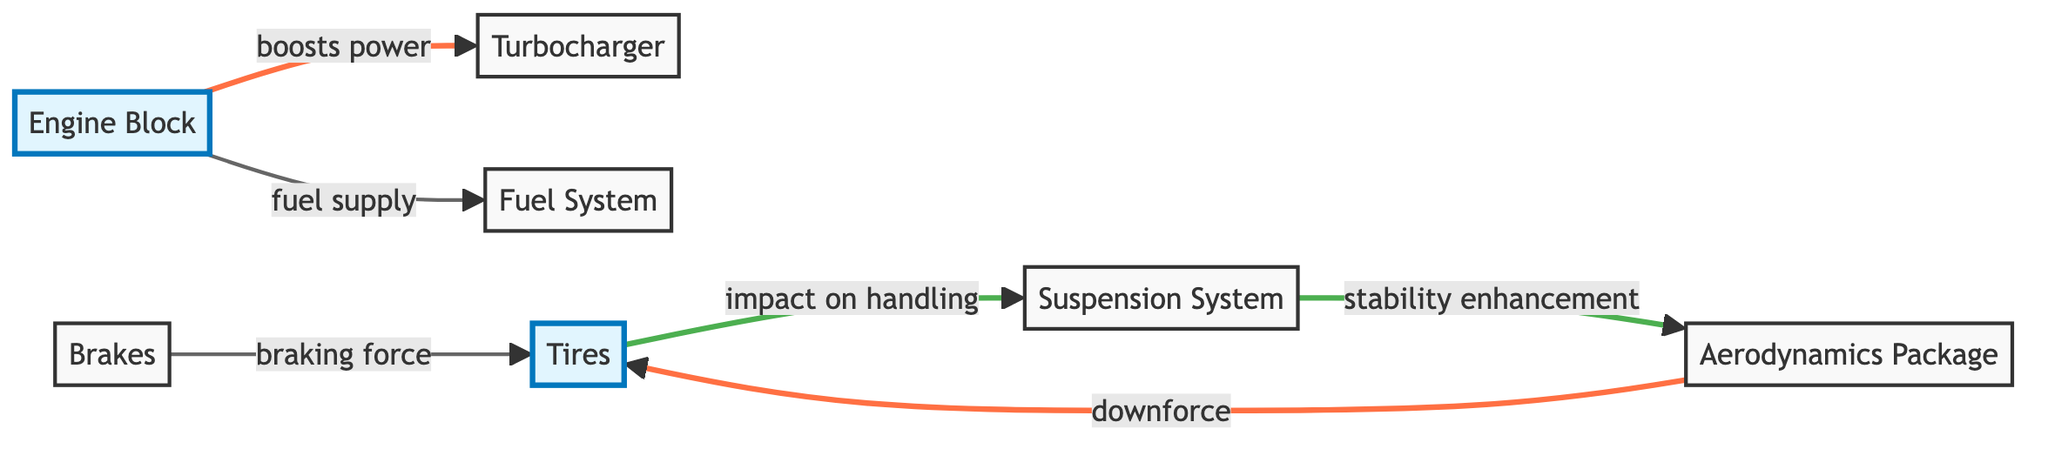What are the main components illustrated in the diagram? The diagram shows seven main components: Engine Block, Turbocharger, Tires, Suspension System, Aerodynamics Package, Brakes, and Fuel System.
Answer: Engine Block, Turbocharger, Tires, Suspension System, Aerodynamics Package, Brakes, Fuel System How many edges are present in the diagram? By counting the connections (edges) between the components, there are a total of six edges linking the nodes.
Answer: 6 What component boosts power to the engine block? The Turbocharger is identified in the diagram as the component that is connected to the Engine Block with the label "boosts power."
Answer: Turbocharger Which component is responsible for decelerating the race car? The Brakes are directly labeled in the diagram as being responsible for the deceleration of the race car.
Answer: Brakes What is the impact of the suspension system on the tires? The edge labeled "impact on handling" indicates that the suspension system affects how the tires maintain contact with the track.
Answer: Impact on handling How does the aerodynamics package affect the tires? The connection labeled "downforce" shows that the aerodynamics package increases grip on the tires due to enhanced downforce.
Answer: Downforce Which two components are connected through the fuel supply relationship? The Engine Block and the Fuel System are connected with the label "fuel supply," indicating their relationship.
Answer: Engine Block, Fuel System What relationships connect the suspension system and the aerodynamics package? The relationship "stability enhancement" shows that the suspension system complements the aerodynamics package for vehicle stability.
Answer: Stability enhancement What does the connection between brakes and tires signify? The connection labeled "braking force" indicates that the brakes apply force to the tires to stop the car.
Answer: Braking force 